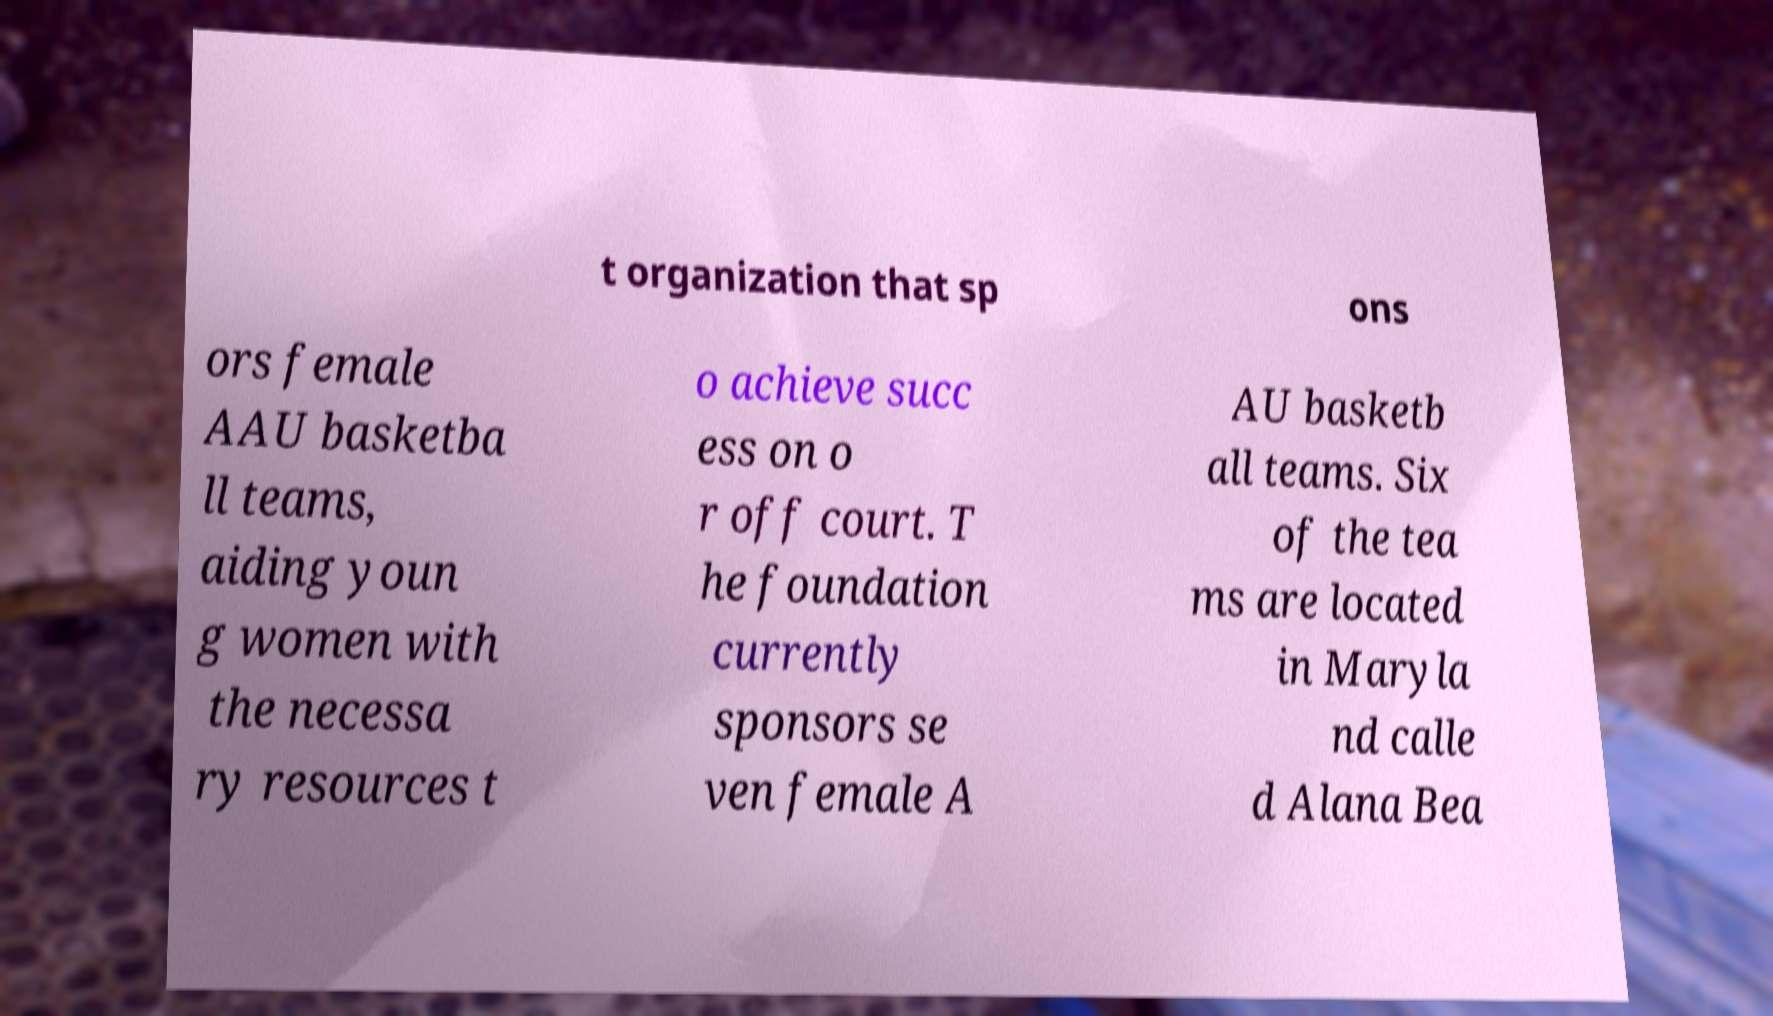I need the written content from this picture converted into text. Can you do that? t organization that sp ons ors female AAU basketba ll teams, aiding youn g women with the necessa ry resources t o achieve succ ess on o r off court. T he foundation currently sponsors se ven female A AU basketb all teams. Six of the tea ms are located in Maryla nd calle d Alana Bea 